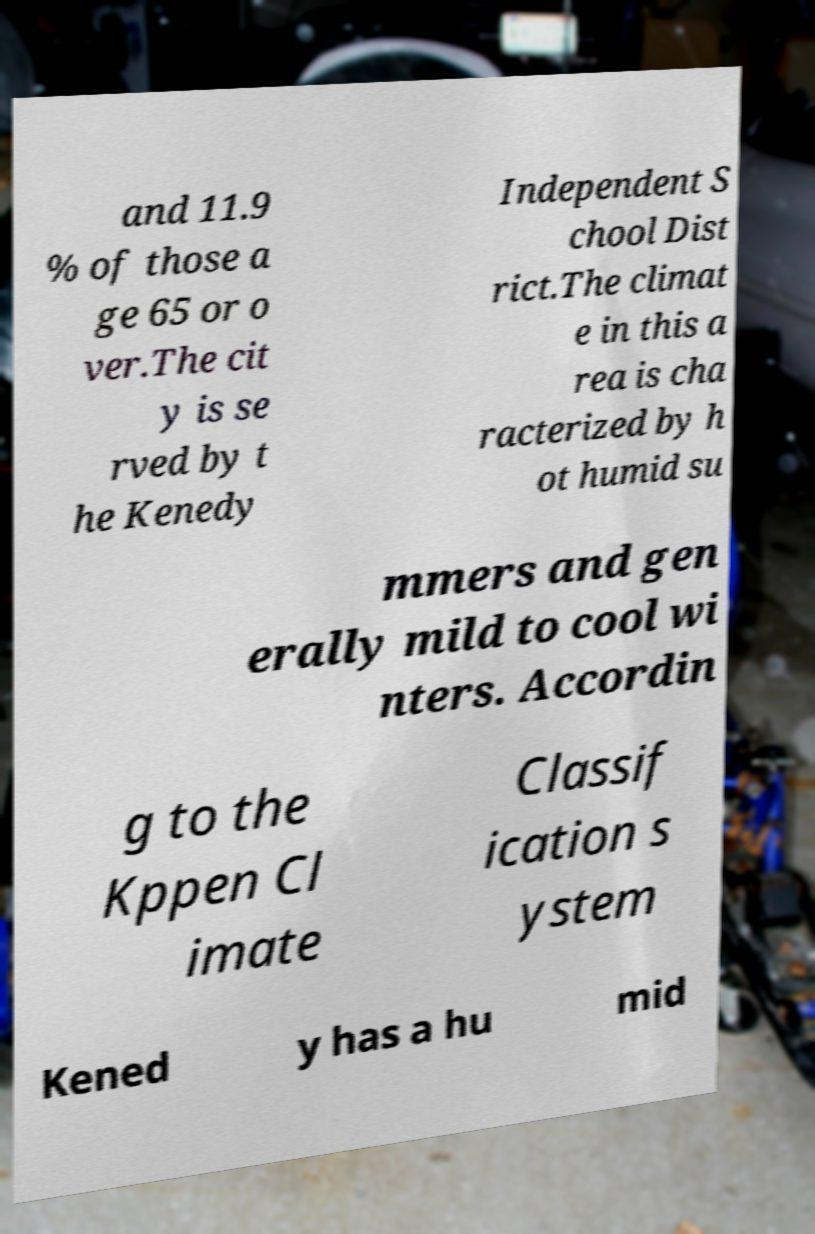Could you extract and type out the text from this image? and 11.9 % of those a ge 65 or o ver.The cit y is se rved by t he Kenedy Independent S chool Dist rict.The climat e in this a rea is cha racterized by h ot humid su mmers and gen erally mild to cool wi nters. Accordin g to the Kppen Cl imate Classif ication s ystem Kened y has a hu mid 